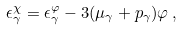Convert formula to latex. <formula><loc_0><loc_0><loc_500><loc_500>\epsilon _ { \gamma } ^ { \chi } = \epsilon _ { \gamma } ^ { \varphi } - 3 ( \mu _ { \gamma } + p _ { \gamma } ) \varphi \, ,</formula> 